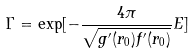Convert formula to latex. <formula><loc_0><loc_0><loc_500><loc_500>\Gamma = \exp [ - \frac { 4 \pi } { \sqrt { g ^ { \prime } ( r _ { 0 } ) f ^ { \prime } ( r _ { 0 } ) } } E ]</formula> 